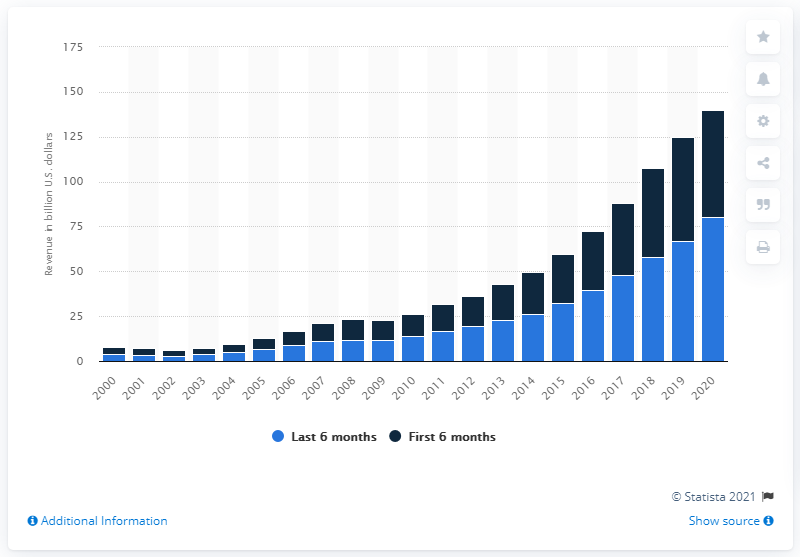Highlight a few significant elements in this photo. The online advertising revenue in the second half of 2019 was 80.5 billion dollars. In the first half of 2020, online advertising revenue in the United States totaled $59.3 billion. 